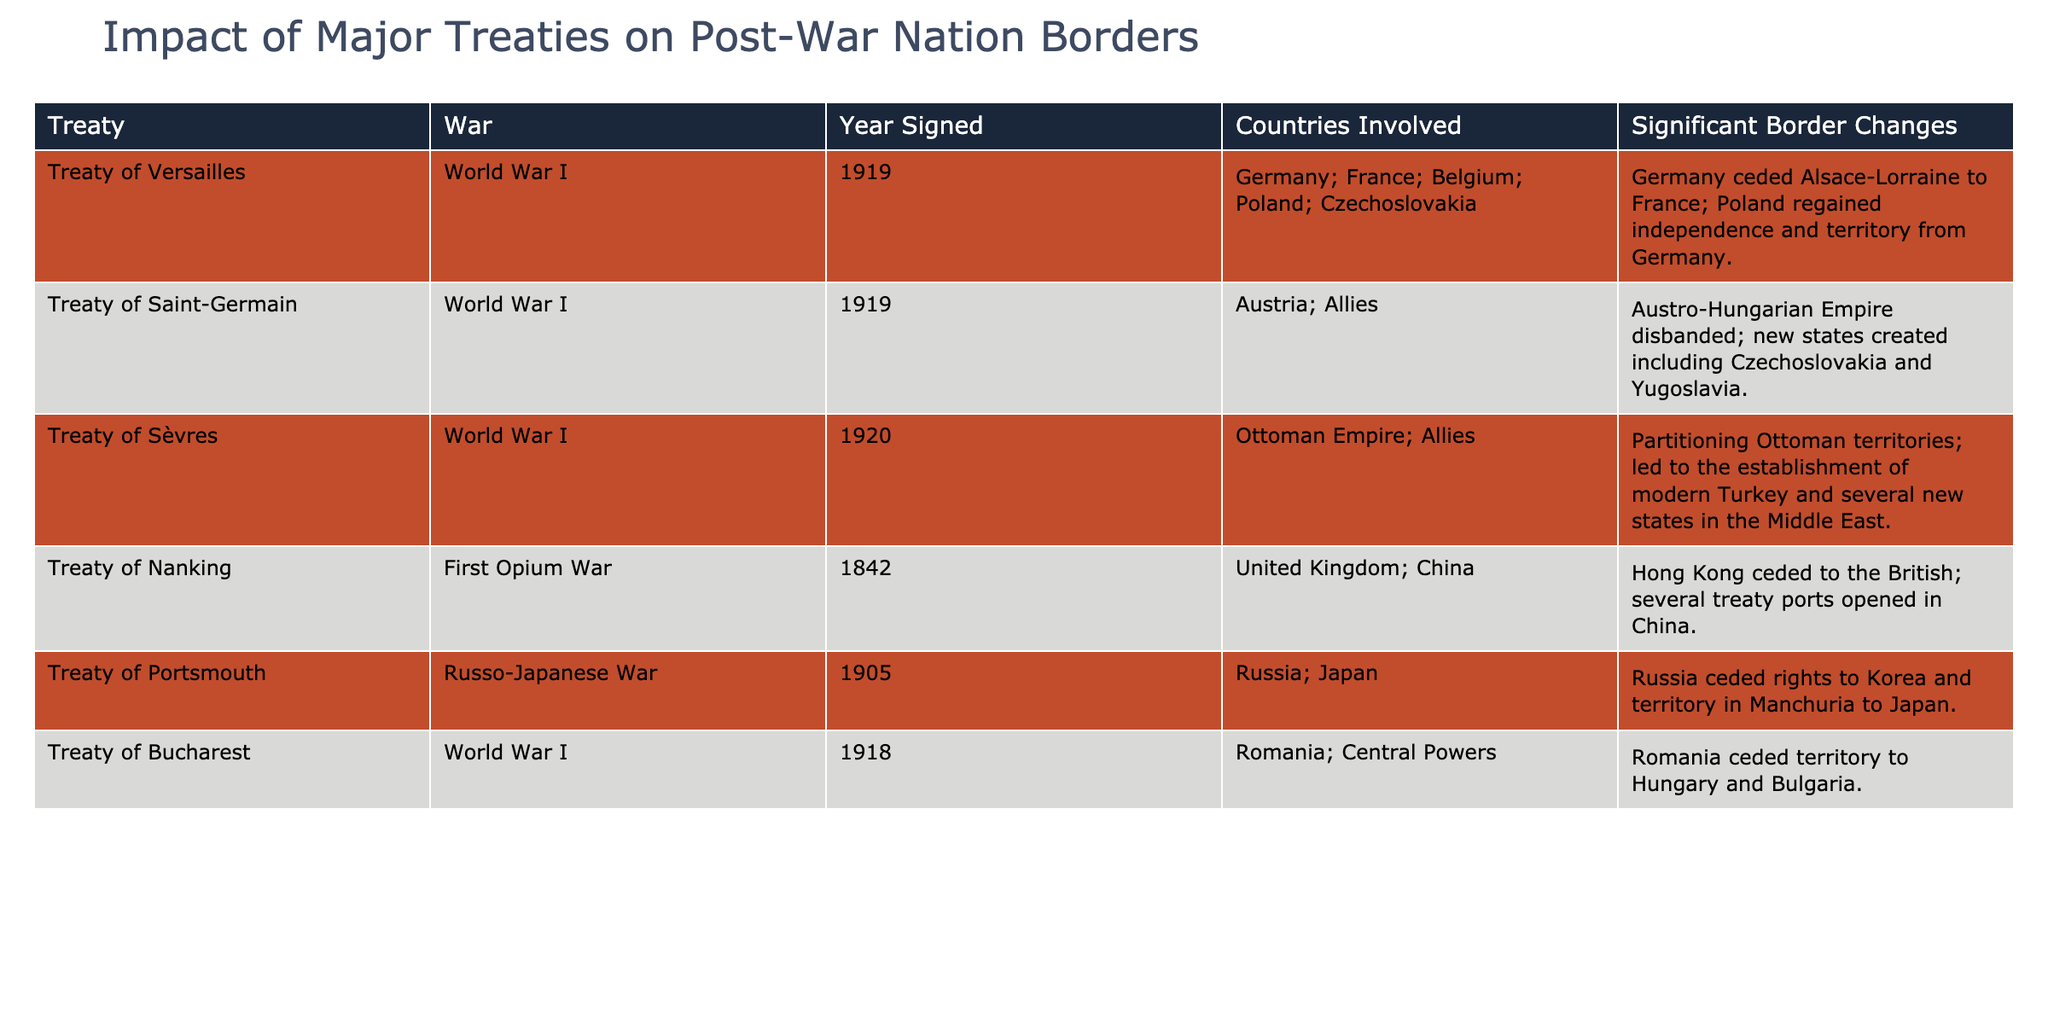What treaty ended World War I? The table lists several treaties related to World War I. By looking at the 'War' column, "Treaty of Versailles" is the only treaty specifically noted for ending World War I.
Answer: Treaty of Versailles Which countries were involved in the Treaty of Sèvres? The 'Countries Involved' column for the Treaty of Sèvres shows "Ottoman Empire; Allies," referring to the states that participated in this treaty after World War I.
Answer: Ottoman Empire; Allies Did the Treaty of Nanking result in any significant border changes for Britain? The 'Significant Border Changes' column for the Treaty of Nanking states that "Hong Kong ceded to the British." This implies that Britain gained territory through this treaty.
Answer: Yes List the border changes resulting from the Treaty of Saint-Germain. The 'Significant Border Changes' column for the Treaty of Saint-Germain indicates "Austro-Hungarian Empire disbanded; new states created including Czechoslovakia and Yugoslavia," summarizing the key territorial adjustments.
Answer: Austro-Hungarian Empire disbanded; new states created including Czechoslovakia and Yugoslavia How many treaties mentioned involved the Ottoman Empire? By scanning the 'Treaty' column, the only treaty involving the Ottoman Empire is the Treaty of Sèvres. Therefore, only one treaty mentions the Ottoman Empire.
Answer: 1 Which treaty had the earliest signing date, and which war was it associated with? The earliest signing date in the 'Year Signed' column is 1842, corresponding to the Treaty of Nanking, which is associated with the First Opium War.
Answer: Treaty of Nanking; First Opium War Did Romania gain any territory from the Treaty of Bucharest? The 'Significant Border Changes' column for the Treaty of Bucharest states that "Romania ceded territory to Hungary and Bulgaria," indicating that Romania did not gain territory from this treaty.
Answer: No What were the main outcomes for Poland from the Treaty of Versailles? The 'Significant Border Changes' column for the Treaty of Versailles specifies "Poland regained independence and territory from Germany," summarizing the critical outcomes for Poland.
Answer: Poland regained independence and territory from Germany 